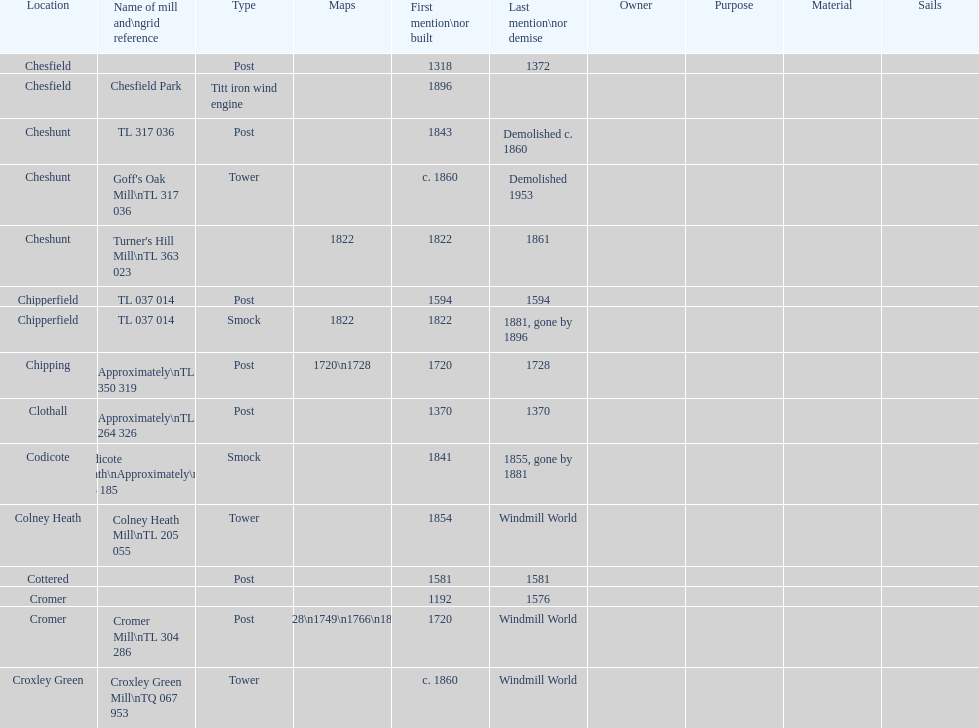What is the total number of mills named cheshunt? 3. 